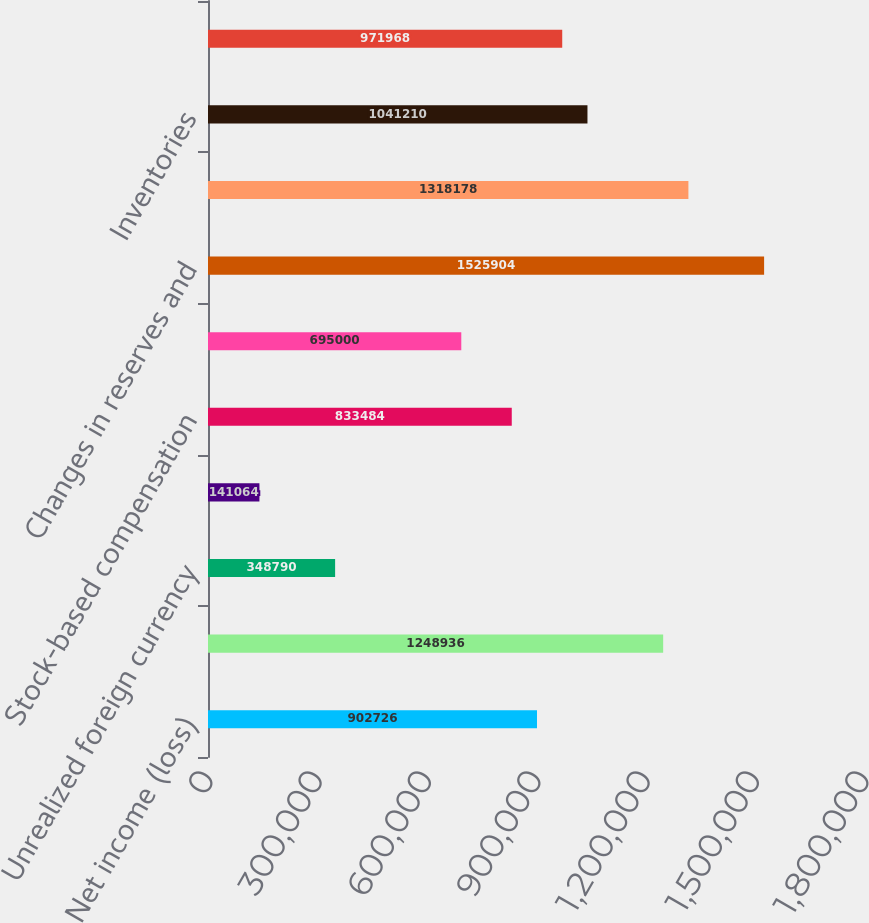Convert chart. <chart><loc_0><loc_0><loc_500><loc_500><bar_chart><fcel>Net income (loss)<fcel>Depreciation and amortization<fcel>Unrealized foreign currency<fcel>Loss on disposal of property<fcel>Stock-based compensation<fcel>Deferred income taxes<fcel>Changes in reserves and<fcel>Accounts receivable<fcel>Inventories<fcel>Prepaid expenses and other<nl><fcel>902726<fcel>1.24894e+06<fcel>348790<fcel>141064<fcel>833484<fcel>695000<fcel>1.5259e+06<fcel>1.31818e+06<fcel>1.04121e+06<fcel>971968<nl></chart> 